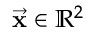Convert formula to latex. <formula><loc_0><loc_0><loc_500><loc_500>\vec { x } \in \mathbb { R } ^ { 2 }</formula> 